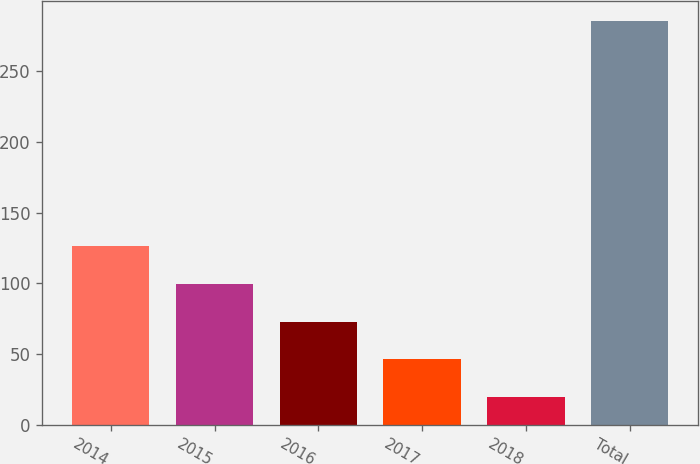Convert chart. <chart><loc_0><loc_0><loc_500><loc_500><bar_chart><fcel>2014<fcel>2015<fcel>2016<fcel>2017<fcel>2018<fcel>Total<nl><fcel>126.02<fcel>99.44<fcel>72.86<fcel>46.28<fcel>19.7<fcel>285.5<nl></chart> 